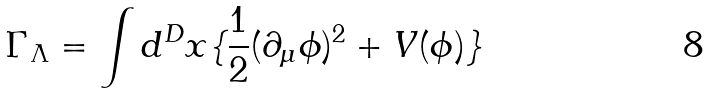<formula> <loc_0><loc_0><loc_500><loc_500>\Gamma _ { \Lambda } = \int d ^ { D } x \{ \frac { 1 } { 2 } ( \partial _ { \mu } \phi ) ^ { 2 } + V ( \phi ) \}</formula> 